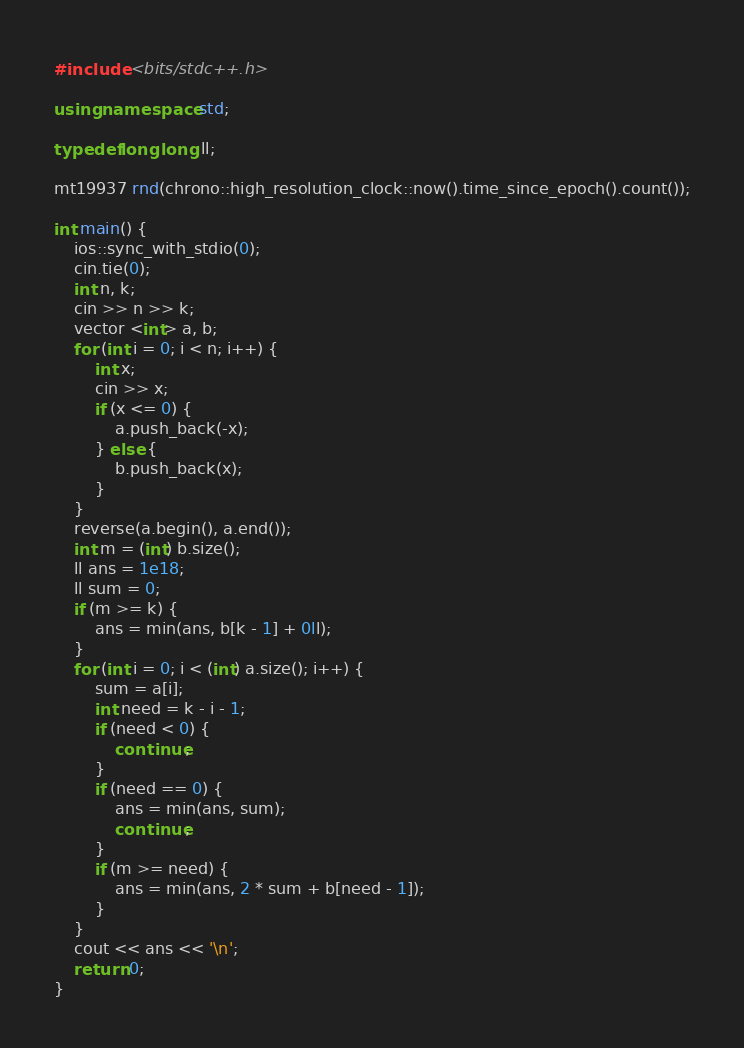Convert code to text. <code><loc_0><loc_0><loc_500><loc_500><_C++_>#include <bits/stdc++.h>

using namespace std;

typedef long long ll;

mt19937 rnd(chrono::high_resolution_clock::now().time_since_epoch().count());

int main() {
    ios::sync_with_stdio(0);
    cin.tie(0);
    int n, k;
    cin >> n >> k;
    vector <int> a, b;
    for (int i = 0; i < n; i++) {
        int x;
        cin >> x;
        if (x <= 0) {
            a.push_back(-x);
        } else {
            b.push_back(x);
        }
    }
    reverse(a.begin(), a.end());
    int m = (int) b.size();
    ll ans = 1e18;
    ll sum = 0;
    if (m >= k) {
        ans = min(ans, b[k - 1] + 0ll);
    }
    for (int i = 0; i < (int) a.size(); i++) {
        sum = a[i];
        int need = k - i - 1;
        if (need < 0) {
            continue;
        }
        if (need == 0) {
            ans = min(ans, sum);
            continue;
        }
        if (m >= need) {
            ans = min(ans, 2 * sum + b[need - 1]);
        }
    }
    cout << ans << '\n';
    return 0;
}</code> 